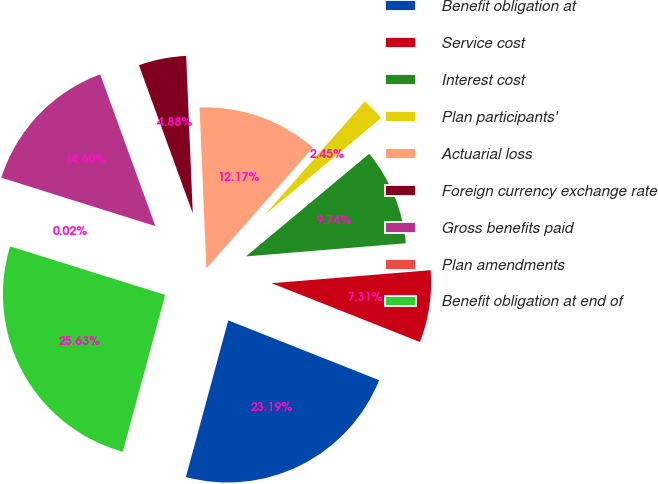Convert chart. <chart><loc_0><loc_0><loc_500><loc_500><pie_chart><fcel>Benefit obligation at<fcel>Service cost<fcel>Interest cost<fcel>Plan participants'<fcel>Actuarial loss<fcel>Foreign currency exchange rate<fcel>Gross benefits paid<fcel>Plan amendments<fcel>Benefit obligation at end of<nl><fcel>23.19%<fcel>7.31%<fcel>9.74%<fcel>2.45%<fcel>12.17%<fcel>4.88%<fcel>14.6%<fcel>0.02%<fcel>25.62%<nl></chart> 